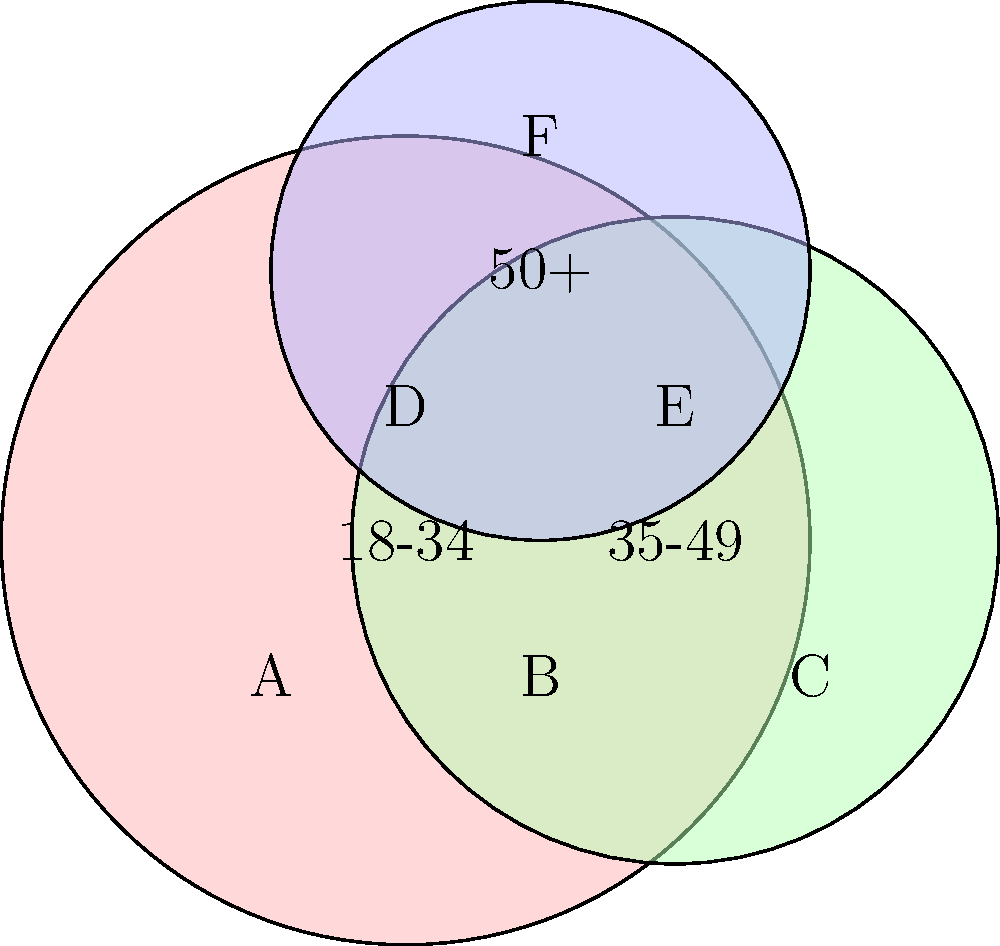As a showrunner facing creative differences with network management, you're analyzing audience demographics for your latest series. The bubble chart represents age groups (18-34, 35-49, 50+) and their overlap. Which segment (labeled A-F) represents viewers aged 35-49 who don't fall into any other age group, and how might this insight help you argue for creative decisions that appeal to this specific demographic? To answer this question, let's break down the bubble chart:

1. The red bubble represents the 18-34 age group.
2. The green bubble represents the 35-49 age group.
3. The blue bubble represents the 50+ age group.

Now, let's analyze each segment:

A: Exclusive to 18-34
B: Overlap of 18-34 and 35-49
C: Exclusive to 35-49
D: Overlap of 18-34 and 50+
E: Overlap of 35-49 and 50+
F: Exclusive to 50+

The segment that represents viewers aged 35-49 who don't fall into any other age group is C.

This insight can help argue for creative decisions by:

1. Focusing on themes and storylines that resonate with the 35-49 demographic.
2. Tailoring character development to reflect the life experiences of this age group.
3. Choosing guest stars or cameos that appeal to this specific audience.
4. Adjusting the show's pacing or format to suit the viewing habits of this demographic.
5. Incorporating cultural references or nostalgia that would be particularly meaningful to this age group.

By emphasizing the unique preferences of this demographic, you can justify creative choices that may differ from the network's initial vision, potentially leading to a more targeted and successful show.
Answer: Segment C; It allows for targeted content creation and justification of creative choices appealing to the exclusive 35-49 demographic. 